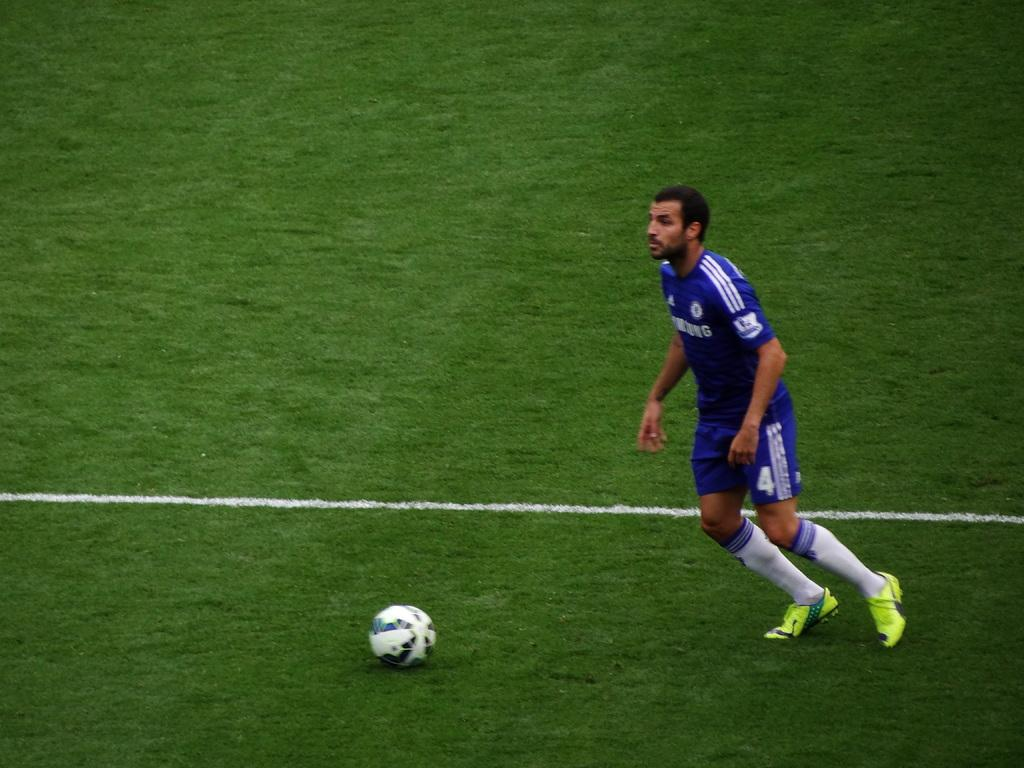<image>
Write a terse but informative summary of the picture. a soccer player with Samsung written on it 